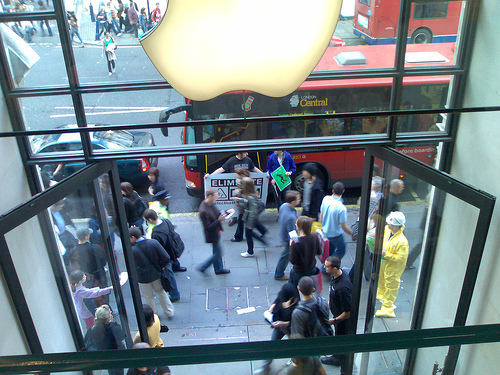<image>
Is there a man next to the woman? No. The man is not positioned next to the woman. They are located in different areas of the scene. 